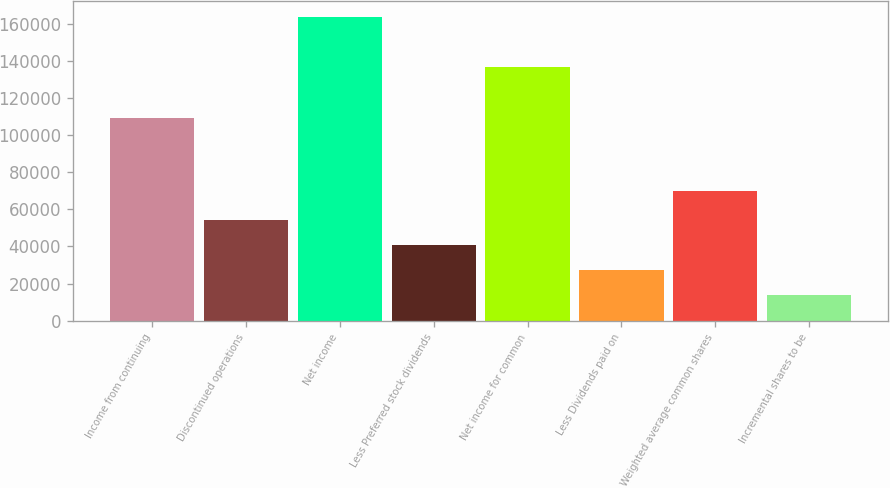Convert chart. <chart><loc_0><loc_0><loc_500><loc_500><bar_chart><fcel>Income from continuing<fcel>Discontinued operations<fcel>Net income<fcel>Less Preferred stock dividends<fcel>Net income for common<fcel>Less Dividends paid on<fcel>Weighted average common shares<fcel>Incremental shares to be<nl><fcel>109204<fcel>54476.2<fcel>163679<fcel>40857.6<fcel>136441<fcel>27238.9<fcel>69578<fcel>13620.3<nl></chart> 